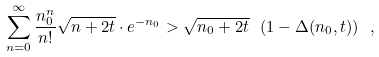<formula> <loc_0><loc_0><loc_500><loc_500>\sum _ { n = 0 } ^ { \infty } \frac { n _ { 0 } ^ { n } } { n ! } \sqrt { n + 2 t } \cdot e ^ { - n _ { 0 } } > \sqrt { n _ { 0 } + 2 t } \ ( 1 - \Delta ( n _ { 0 } , t ) ) \ ,</formula> 